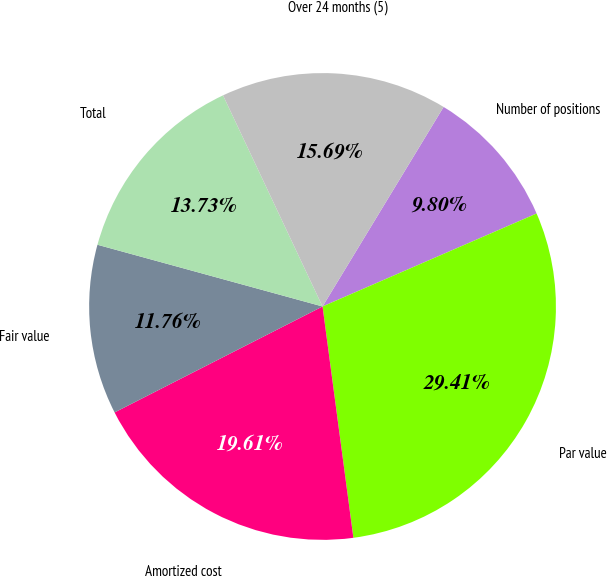Convert chart. <chart><loc_0><loc_0><loc_500><loc_500><pie_chart><fcel>Number of positions<fcel>Par value<fcel>Amortized cost<fcel>Fair value<fcel>Total<fcel>Over 24 months (5)<nl><fcel>9.8%<fcel>29.41%<fcel>19.61%<fcel>11.76%<fcel>13.73%<fcel>15.69%<nl></chart> 